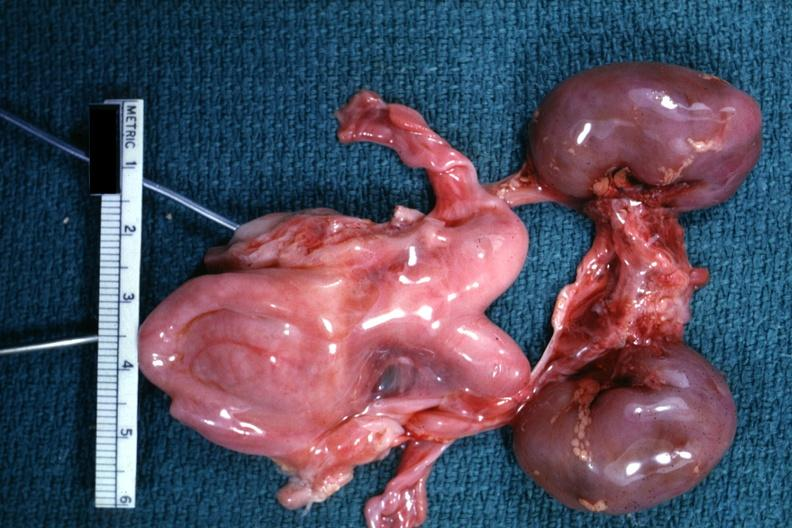what shown lesion?
Answer the question using a single word or phrase. Infant organs 